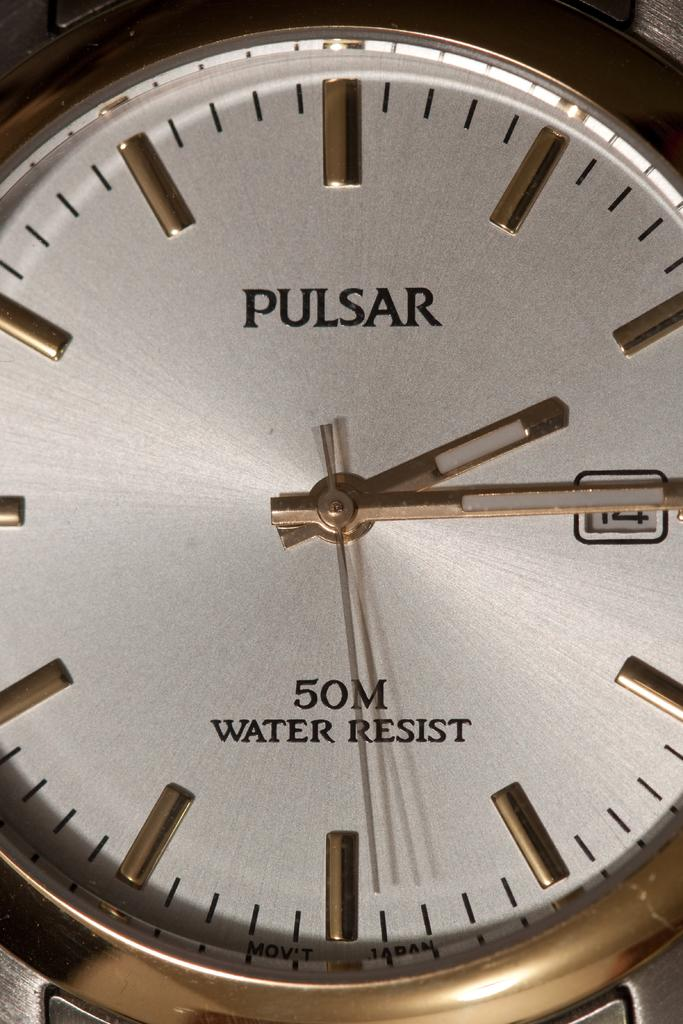What type of object is in the image? There is a wrist watch in the image. What brand or model is the wrist watch? The wrist watch has "pulsar" written on it. What feature does the wrist watch have? The wrist watch has "water resist" written on it. What type of drum can be seen in the image? There is no drum present in the image; it features a wrist watch. How much dirt is visible on the wrist watch in the image? There is no dirt visible on the wrist watch in the image. 